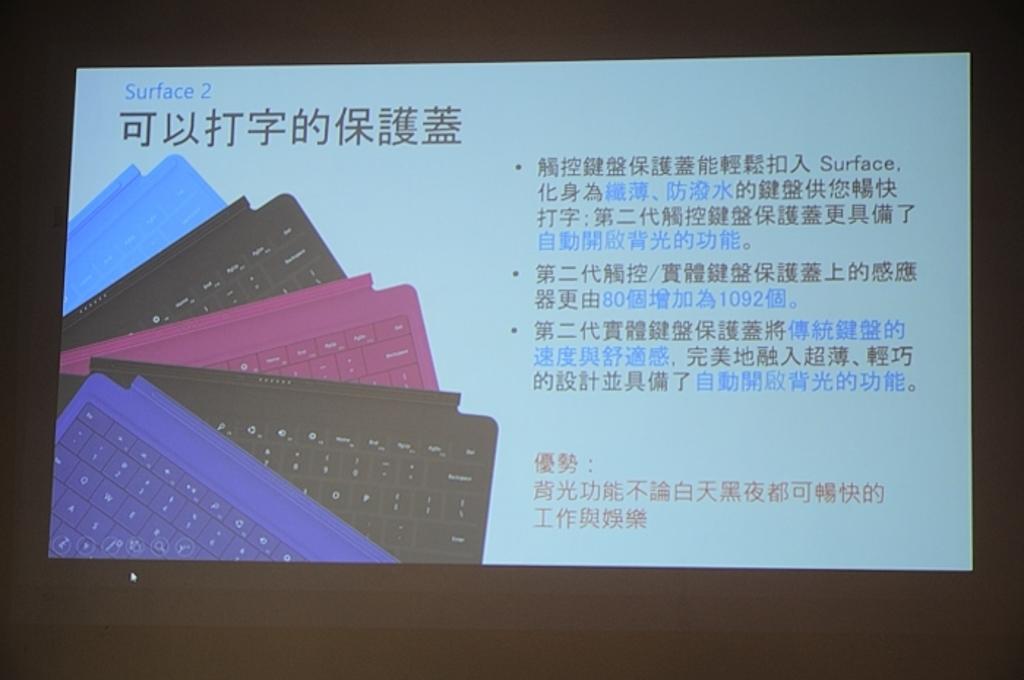What's the name at the top left corner?
Provide a short and direct response. Surface 2. 